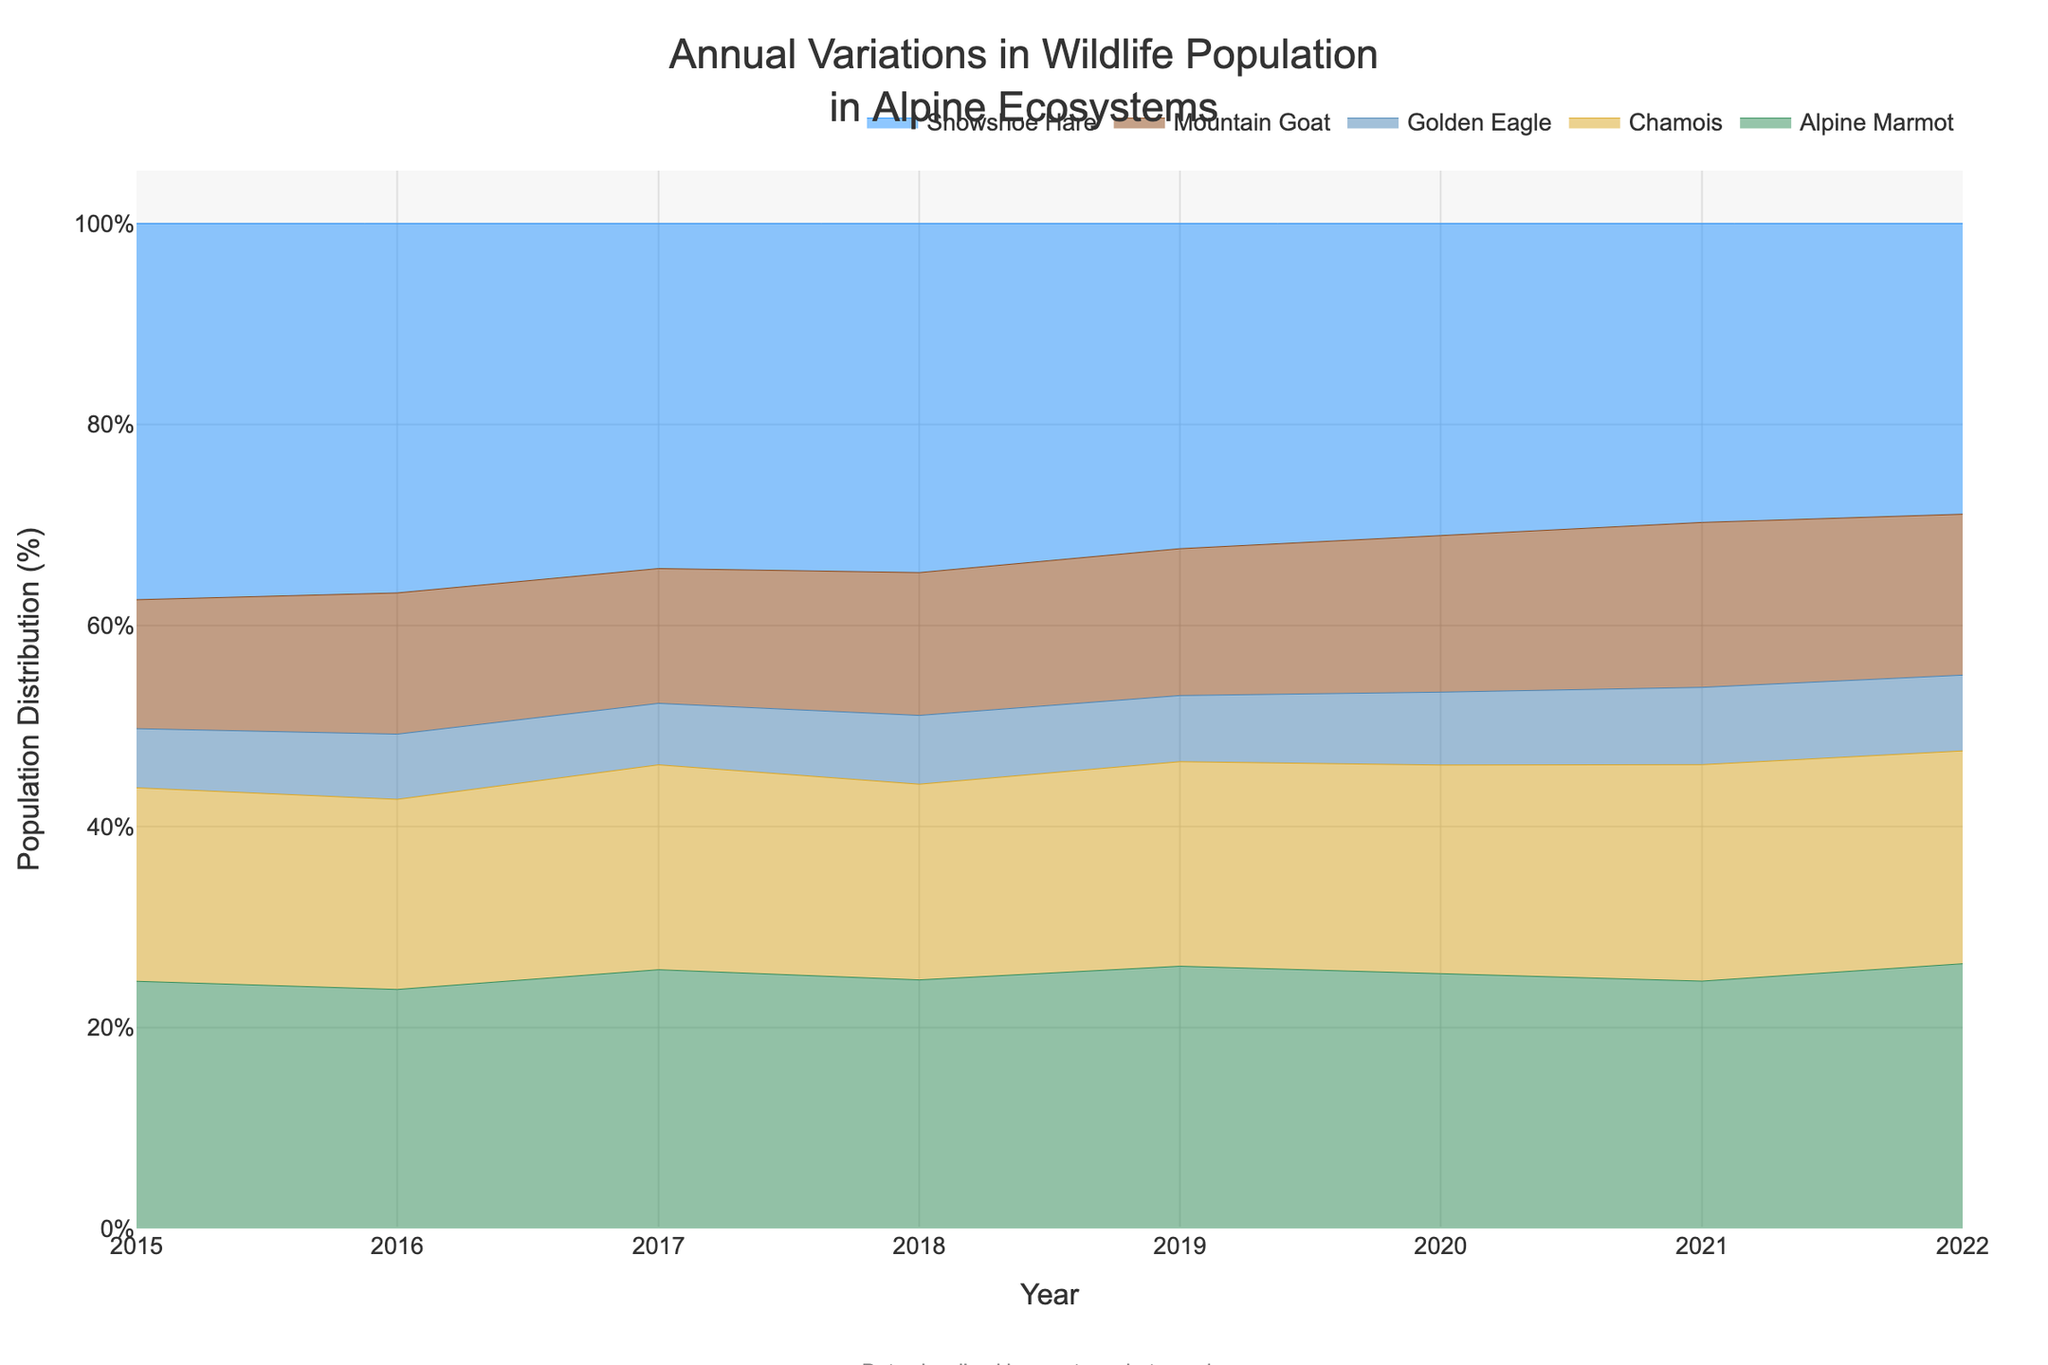What is the title of the figure? The title of the figure is typically found at the top of the plot and usually in a larger or bolder font. In this case, it states what the data is about.
Answer: Annual Variations in Wildlife Population in Alpine Ecosystems What are the colors representing different species in the figure? Each species is represented by a different color. The colors are used to distinguish between Mountain Goat, Alpine Marmot, Golden Eagle, Chamois, and Snowshoe Hare.
Answer: Mountain Goat: green, Alpine Marmot: gold, Golden Eagle: blue, Chamois: brown, Snowshoe Hare: light blue Which species had the highest population percentage in 2016? To determine the species with the highest population percentage, look at the year 2016 and compare the height of the colored sections. The species with the tallest section at this point has the highest population percentage.
Answer: Snowshoe Hare How did the population percentage of the Golden Eagle change from 2015 to 2022? Trace the section of the figure representing the Golden Eagle from 2015 (55) to 2022 (73). Compare the starting and ending values to observe the change.
Answer: It increased Which species showed the most significant population growth in percentage terms over the years? By observing the entire figure, note the species whose section increased the most in height from left (2015) to right (2022). This indicates the most considerable percentage growth.
Answer: Mountain Goat Compare the population trends of Mountain Goat and Chamois between 2017 and 2020. Identify the sections for Mountain Goat and Chamois between 2017 and 2020. Note the changes in their heights over these years.
Answer: Both increased, but the Mountain Goat's population percentage grew more significantly What is the trend of Snowshoe Hare's population percentage over the years? By following the section for Snowshoe Hare from left to right (2015 to 2022), observe the general direction (increase, decrease, or fluctuating).
Answer: It decreased What percentage of the population did Alpine Marmots contribute in 2019? Locate the year 2019 and examine the colored section representing Alpine Marmots. Note the percentage value.
Answer: Approximately 24% Between which pairs of years did the population of the Golden Eagle increase the most? Identify the Golden Eagle section for each year, and then compare the changes between each pair of years. Find the pair with the maximum increase in height.
Answer: 2020 to 2021 